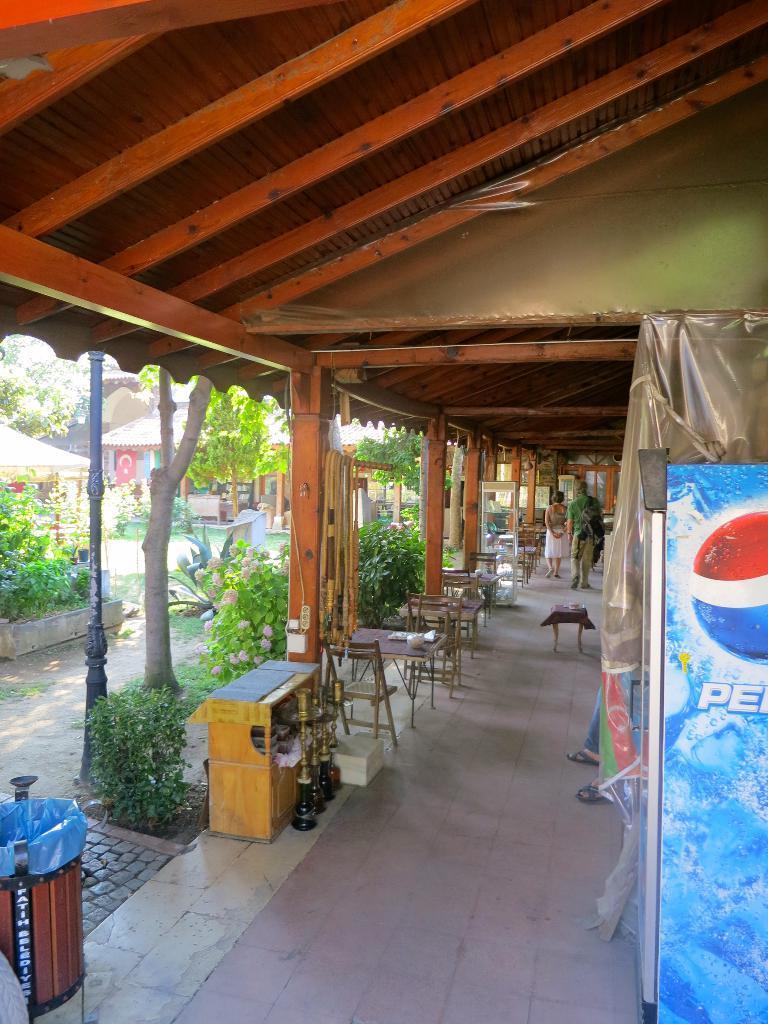How would you summarize this image in a sentence or two? A couple are walking in a corridor of a restaurant with some tables and chairs. There are some plants and trees beside the corridor. 